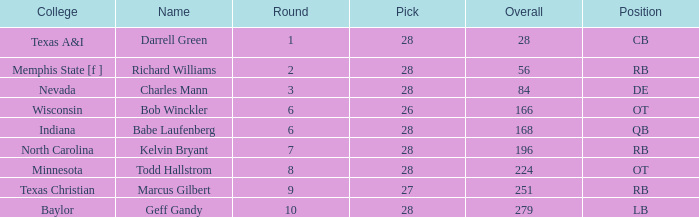What is the highest pick of the player from texas a&i with an overall less than 28? None. 